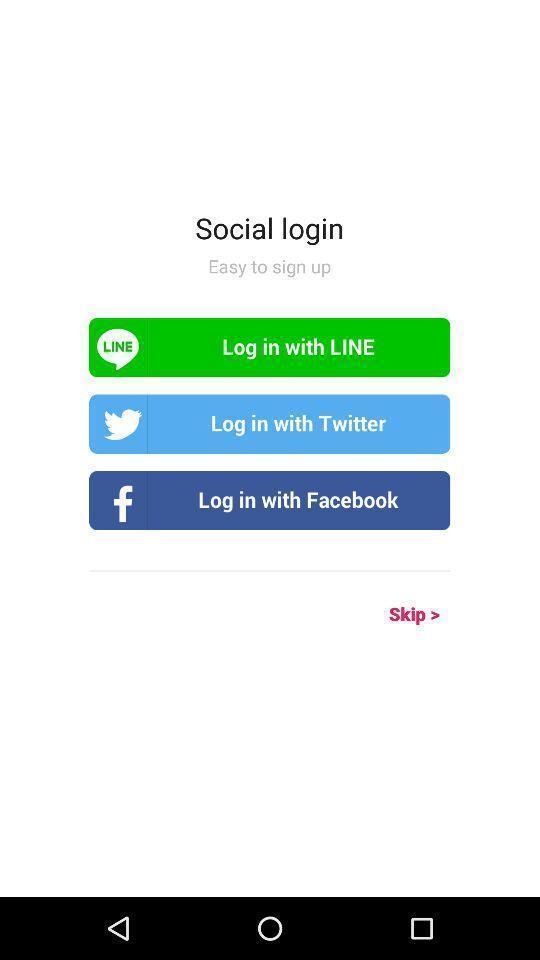Describe the key features of this screenshot. Page with log in options with social apps. 